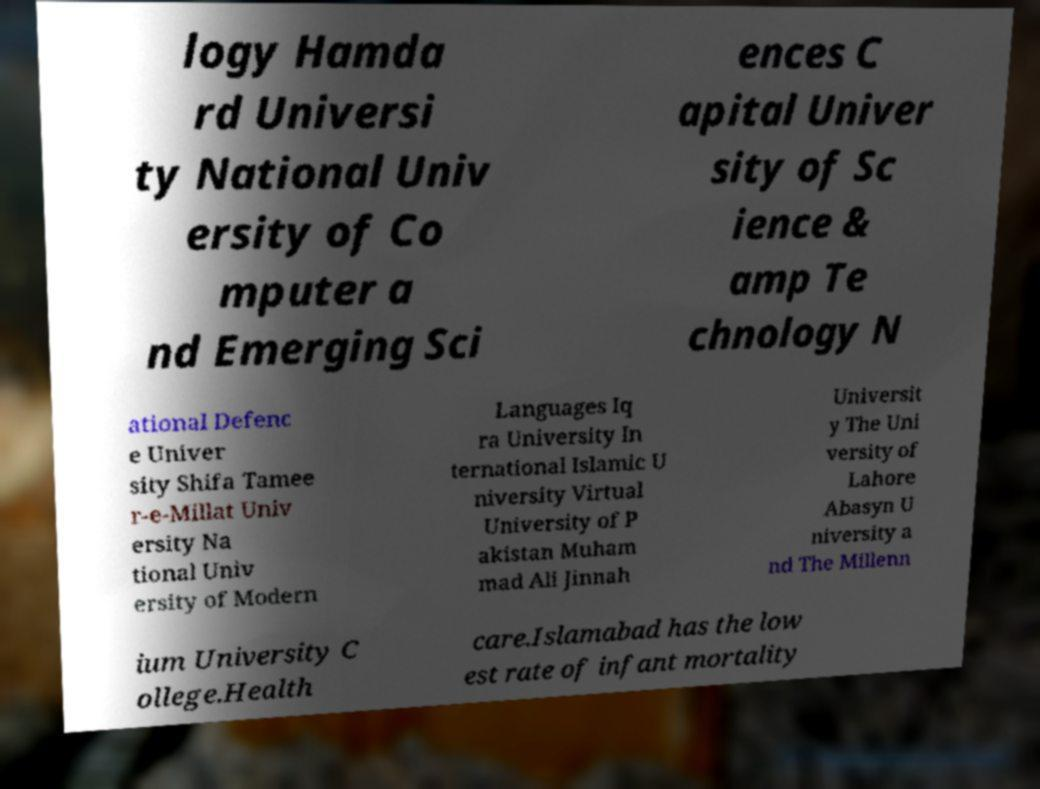Please read and relay the text visible in this image. What does it say? logy Hamda rd Universi ty National Univ ersity of Co mputer a nd Emerging Sci ences C apital Univer sity of Sc ience & amp Te chnology N ational Defenc e Univer sity Shifa Tamee r-e-Millat Univ ersity Na tional Univ ersity of Modern Languages Iq ra University In ternational Islamic U niversity Virtual University of P akistan Muham mad Ali Jinnah Universit y The Uni versity of Lahore Abasyn U niversity a nd The Millenn ium University C ollege.Health care.Islamabad has the low est rate of infant mortality 